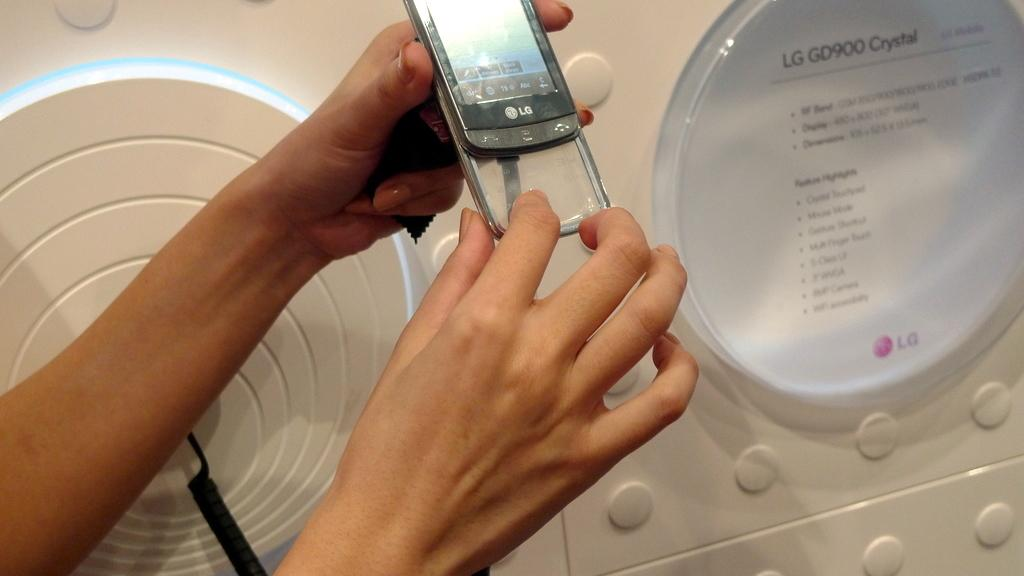Provide a one-sentence caption for the provided image. a silver phone with a women holding this item. 